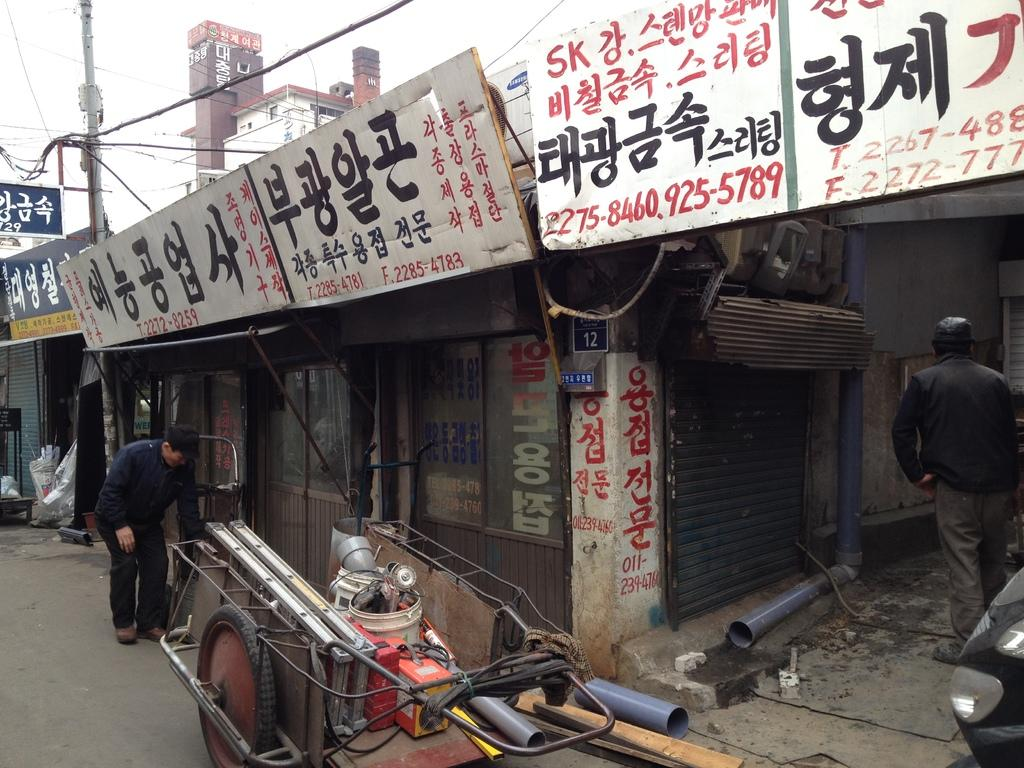What type of structures are located at the center of the image? There are shops in the image. Where is the person in the image positioned? The person is in the image, but their exact location is not specified. What is the cart in the image used for? The cart contains many objects, which suggests it might be used for carrying or transporting items. What is visible at the bottom of the image? There is a road visible at the bottom of the image. What is the tall, vertical object in the image? There is an electric pole in the image. What type of design is visible on the side of the balloon in the image? There is no balloon present in the image, so it is not possible to answer that question. 